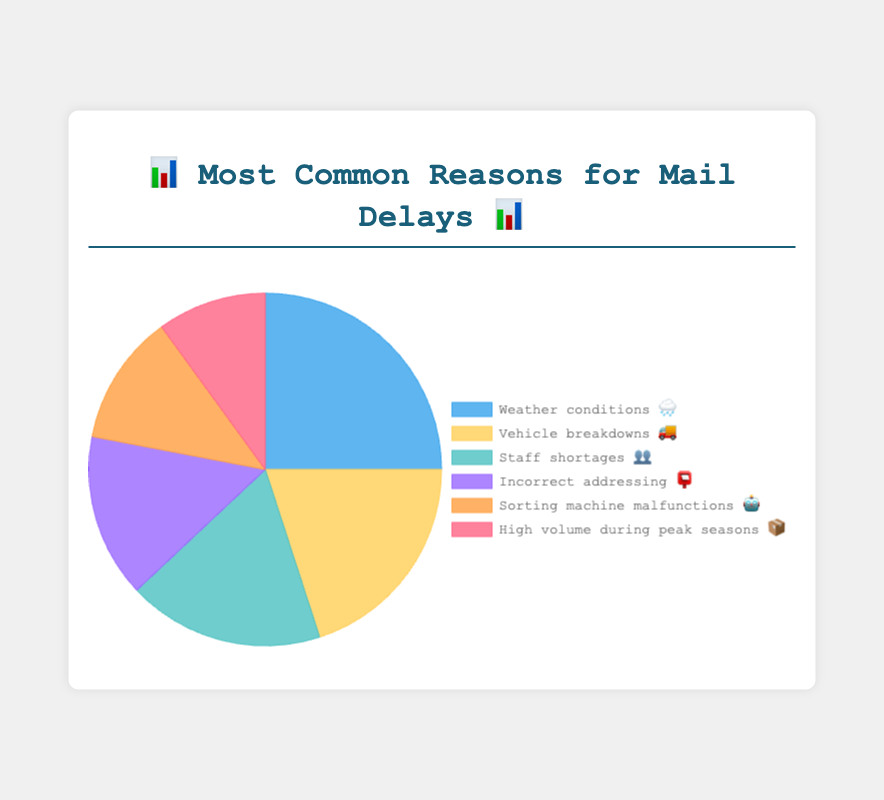What is the most common reason for mail delays shown in the chart? The chart has different sections each representing a reason for mail delays with respective percentages and emojis. The largest section represents "Weather conditions 🌧️" with 25% as the maximum percentage
Answer: Weather conditions 🌧️ What percentage of mail delays is caused by vehicle breakdowns 🚚? Locate the segment of the chart labeled "Vehicle breakdowns 🚚" and note the percentage displayed. It shows 20%
Answer: 20% How do the mail delays caused by staff shortages 👥 compare to those caused by incorrect addressing 📮? Identify the percentages for both staff shortages (18%) 👥 and incorrect addressing (15%) 📮, then compare them. 18% is greater than 15%
Answer: Staff shortages 👥 cause more delays What is the combined percentage of mail delays due to sorting machine malfunctions 🤖 and high volume during peak seasons 📦? Add the percentage of sorting machine malfunctions (12%) 🤖 to the percentage of high volume during peak seasons (10%) 📦. Sum = 12% + 10% = 22%
Answer: 22% Which has a higher contribution to mail delays: vehicle breakdowns 🚚 or staff shortages 👥? Compare the segments of the chart for vehicle breakdowns 🚚 (20%) and staff shortages 👥 (18%), noting that 20% is greater than 18%
Answer: Vehicle breakdowns 🚚 What is the least common reason for mail delays? Refer to the segments with the percentages, and identify that the smallest section labeled "High volume during peak seasons 📦" has the lowest value at 10%
Answer: High volume during peak seasons 📦 What is the relative difference between delays caused by incorrect addressing 📮 and sorting machine malfunctions 🤖? Subtract the smaller percentage (12% for sorting machine malfunctions 🤖) from the larger percentage (15% for incorrect addressing 📮). Difference = 15% - 12% = 3%
Answer: 3% Which reason contributes approximately one-fifth of all mail delays? One-fifth represents about 20%. The chart segment for vehicle breakdowns 🚚 represents 20%
Answer: Vehicle breakdowns 🚚 How many reasons cause mail delays above 15%? Identify the sections with percentages above 15% (Weather conditions 🌧️ - 25%, Vehicle breakdowns 🚚 - 20%, and Staff shortages 👥 - 18%). There are three such reasons
Answer: 3 